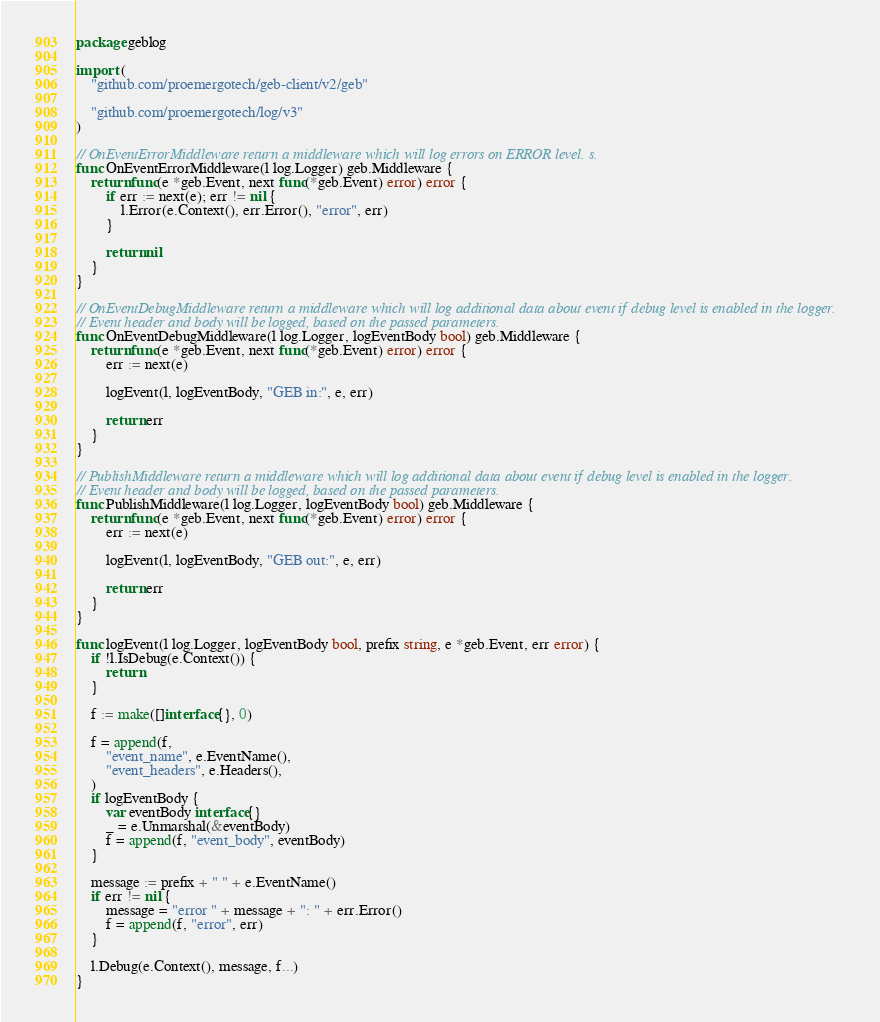<code> <loc_0><loc_0><loc_500><loc_500><_Go_>package geblog

import (
	"github.com/proemergotech/geb-client/v2/geb"

	"github.com/proemergotech/log/v3"
)

// OnEventErrorMiddleware return a middleware which will log errors on ERROR level. s.
func OnEventErrorMiddleware(l log.Logger) geb.Middleware {
	return func(e *geb.Event, next func(*geb.Event) error) error {
		if err := next(e); err != nil {
			l.Error(e.Context(), err.Error(), "error", err)
		}

		return nil
	}
}

// OnEventDebugMiddleware return a middleware which will log additional data about event if debug level is enabled in the logger.
// Event header and body will be logged, based on the passed parameters.
func OnEventDebugMiddleware(l log.Logger, logEventBody bool) geb.Middleware {
	return func(e *geb.Event, next func(*geb.Event) error) error {
		err := next(e)

		logEvent(l, logEventBody, "GEB in:", e, err)

		return err
	}
}

// PublishMiddleware return a middleware which will log additional data about event if debug level is enabled in the logger.
// Event header and body will be logged, based on the passed parameters.
func PublishMiddleware(l log.Logger, logEventBody bool) geb.Middleware {
	return func(e *geb.Event, next func(*geb.Event) error) error {
		err := next(e)

		logEvent(l, logEventBody, "GEB out:", e, err)

		return err
	}
}

func logEvent(l log.Logger, logEventBody bool, prefix string, e *geb.Event, err error) {
	if !l.IsDebug(e.Context()) {
		return
	}

	f := make([]interface{}, 0)

	f = append(f,
		"event_name", e.EventName(),
		"event_headers", e.Headers(),
	)
	if logEventBody {
		var eventBody interface{}
		_ = e.Unmarshal(&eventBody)
		f = append(f, "event_body", eventBody)
	}

	message := prefix + " " + e.EventName()
	if err != nil {
		message = "error " + message + ": " + err.Error()
		f = append(f, "error", err)
	}

	l.Debug(e.Context(), message, f...)
}
</code> 